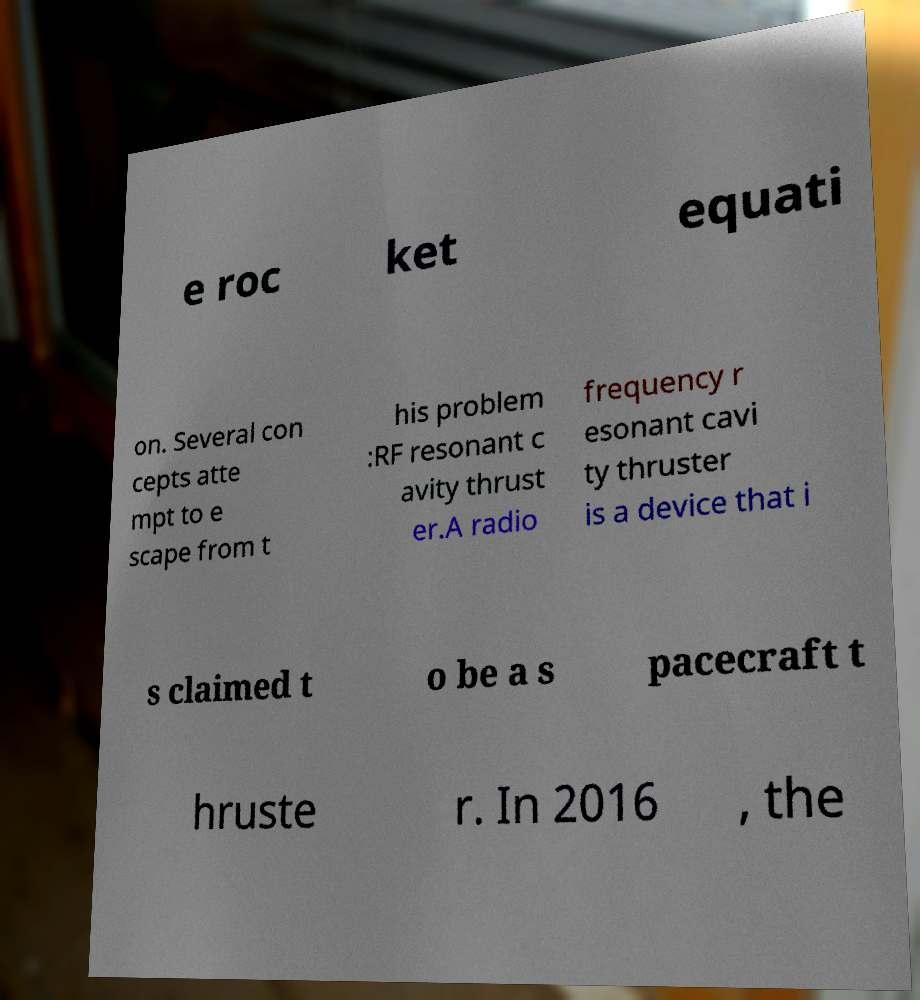Please read and relay the text visible in this image. What does it say? e roc ket equati on. Several con cepts atte mpt to e scape from t his problem :RF resonant c avity thrust er.A radio frequency r esonant cavi ty thruster is a device that i s claimed t o be a s pacecraft t hruste r. In 2016 , the 